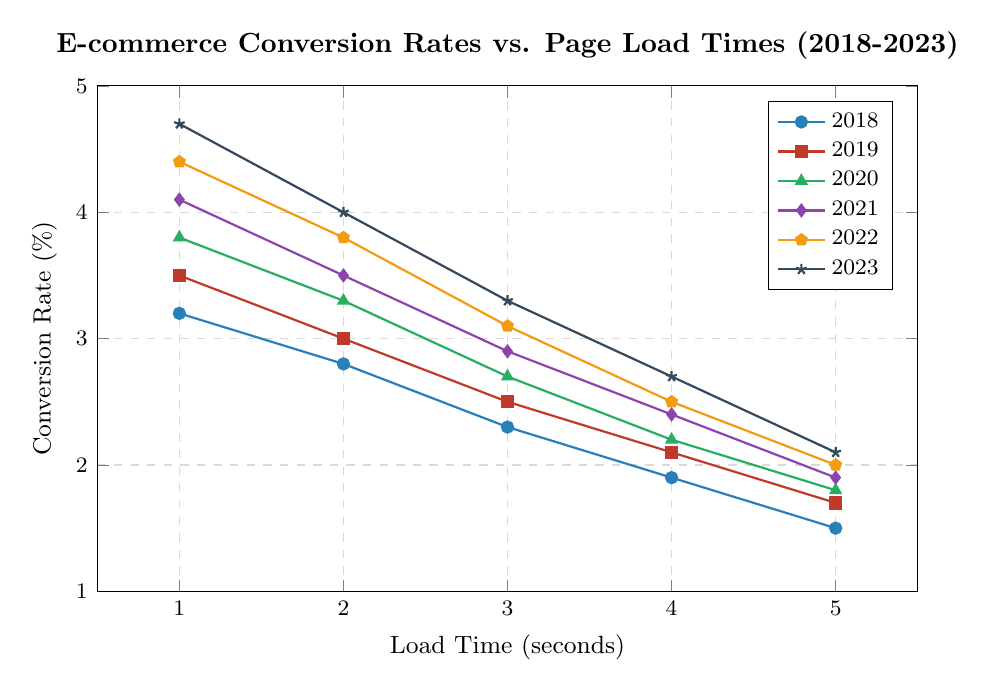Which year has the highest conversion rate at 1 second load time? To find the highest conversion rate at a 1-second load time, look at the data points corresponding to a load time of 1 second. The highest value is observed in the year 2023 with a conversion rate of 4.7%.
Answer: 2023 How does the conversion rate in 2021 at 5 seconds load time compare to 2018 at the same load time? Find the conversion rates for both years at 5 seconds load time. In 2021, it is 1.9%, while in 2018, it is 1.5%. 1.9% is greater than 1.5%.
Answer: 2021 > 2018 Which year shows the most significant decrease in conversion rate from 2018 to 2023 for a load time of 3 seconds? Look at the conversion rates for 3 seconds in both 2018 and 2023. The decrease is from 2.3% in 2018 to 3.3% in 2023, which is actually an increase. Re-evaluate statements and make sure correctly interpreted a decrease.
Answer: none What is the average conversion rate for 2022 across all load times? Calculate the average conversion rate for the year 2022 by summing all the conversion rates and dividing by the number of data points: (4.4 + 3.8 + 3.1 + 2.5 + 2.0)/5 = 3.16%.
Answer: 3.16% Has the conversion rate for a 4-second load time increased or decreased from 2020 to 2023? Compare the conversion rates for a 4-second load time. In 2020, it is 2.2%, and in 2023, it is 2.7%. Since 2.7% is greater than 2.2%, there is an increase.
Answer: Increased What is the median conversion rate for 2019? Arrange the conversion rates for 2019 and find the middle value. The values are: 3.5, 3.0, 2.5, 2.1, 1.7, the median is the middle one, which is 2.5%.
Answer: 2.5% Between which years do we observe the greatest improvement in conversion rate for a load time of 3 seconds? Compare the conversion rates at 3 seconds load time across all the years. The values are: 2018 - 2.3%, 2019 - 2.5%, 2020 - 2.7%, 2021 - 2.9%, 2022 - 3.1%, 2023 - 3.3%. The greatest improvement is observed from 2022 to 2023.
Answer: 2022 to 2023 